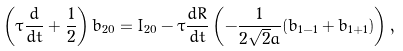<formula> <loc_0><loc_0><loc_500><loc_500>\left ( \tau \frac { d } { d t } + \frac { 1 } { 2 } \right ) b _ { 2 0 } = I _ { 2 0 } - \tau \frac { d R } { d t } \left ( - \frac { 1 } { 2 \sqrt { 2 } a } ( b _ { 1 - 1 } + b _ { 1 + 1 } ) \right ) ,</formula> 